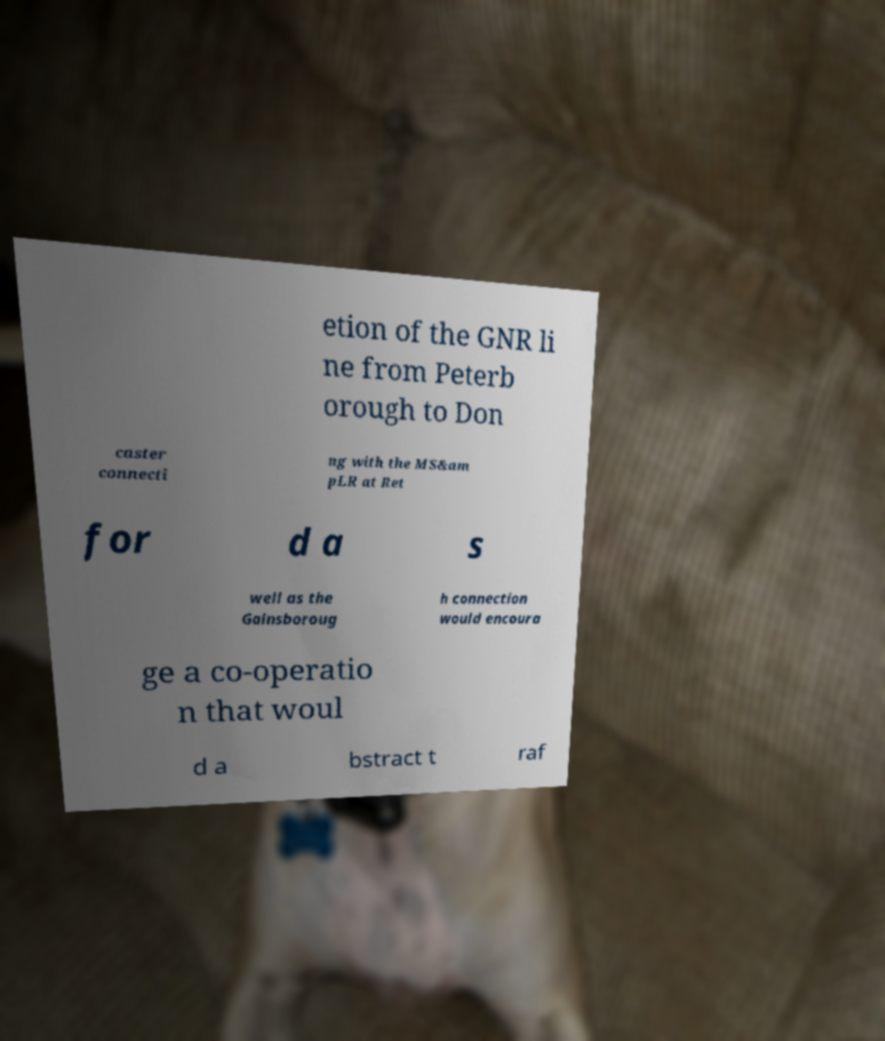What messages or text are displayed in this image? I need them in a readable, typed format. etion of the GNR li ne from Peterb orough to Don caster connecti ng with the MS&am pLR at Ret for d a s well as the Gainsboroug h connection would encoura ge a co-operatio n that woul d a bstract t raf 